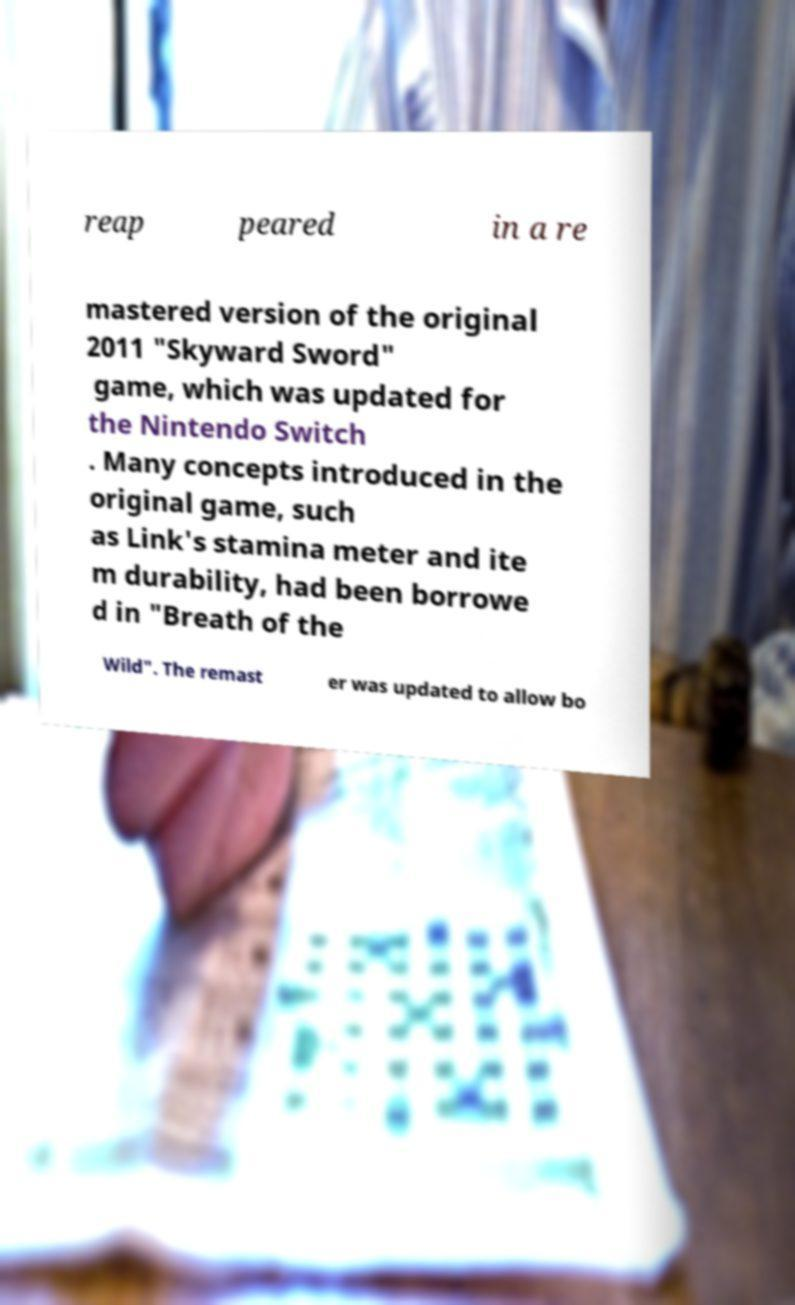Could you assist in decoding the text presented in this image and type it out clearly? reap peared in a re mastered version of the original 2011 "Skyward Sword" game, which was updated for the Nintendo Switch . Many concepts introduced in the original game, such as Link's stamina meter and ite m durability, had been borrowe d in "Breath of the Wild". The remast er was updated to allow bo 